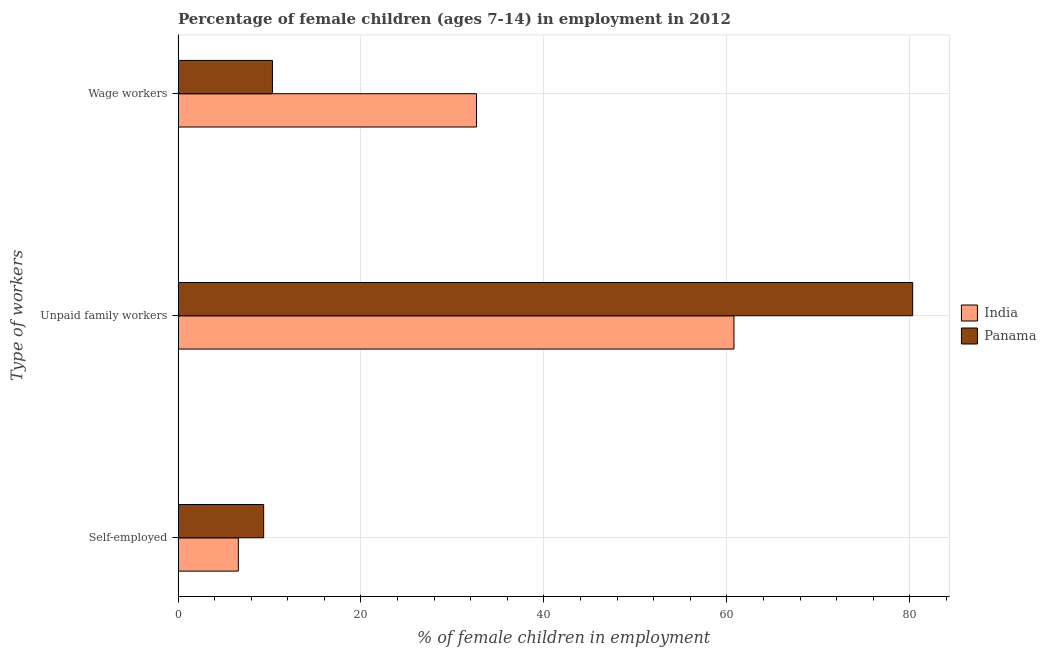How many groups of bars are there?
Your answer should be very brief. 3. Are the number of bars per tick equal to the number of legend labels?
Give a very brief answer. Yes. Are the number of bars on each tick of the Y-axis equal?
Your response must be concise. Yes. How many bars are there on the 1st tick from the top?
Ensure brevity in your answer.  2. How many bars are there on the 2nd tick from the bottom?
Provide a succinct answer. 2. What is the label of the 1st group of bars from the top?
Ensure brevity in your answer.  Wage workers. What is the percentage of children employed as unpaid family workers in Panama?
Your answer should be compact. 80.32. Across all countries, what is the maximum percentage of self employed children?
Ensure brevity in your answer.  9.36. Across all countries, what is the minimum percentage of children employed as wage workers?
Your response must be concise. 10.32. In which country was the percentage of children employed as unpaid family workers maximum?
Provide a short and direct response. Panama. In which country was the percentage of children employed as unpaid family workers minimum?
Give a very brief answer. India. What is the total percentage of self employed children in the graph?
Provide a succinct answer. 15.95. What is the difference between the percentage of children employed as unpaid family workers in Panama and that in India?
Your answer should be very brief. 19.54. What is the difference between the percentage of children employed as unpaid family workers in Panama and the percentage of children employed as wage workers in India?
Provide a succinct answer. 47.69. What is the average percentage of children employed as unpaid family workers per country?
Ensure brevity in your answer.  70.55. What is the difference between the percentage of children employed as wage workers and percentage of self employed children in India?
Make the answer very short. 26.04. What is the ratio of the percentage of children employed as wage workers in Panama to that in India?
Offer a terse response. 0.32. Is the difference between the percentage of children employed as wage workers in Panama and India greater than the difference between the percentage of children employed as unpaid family workers in Panama and India?
Your response must be concise. No. What is the difference between the highest and the second highest percentage of self employed children?
Make the answer very short. 2.77. What is the difference between the highest and the lowest percentage of children employed as unpaid family workers?
Your answer should be compact. 19.54. In how many countries, is the percentage of self employed children greater than the average percentage of self employed children taken over all countries?
Give a very brief answer. 1. What does the 1st bar from the top in Unpaid family workers represents?
Your answer should be compact. Panama. Is it the case that in every country, the sum of the percentage of self employed children and percentage of children employed as unpaid family workers is greater than the percentage of children employed as wage workers?
Make the answer very short. Yes. Are all the bars in the graph horizontal?
Make the answer very short. Yes. How many countries are there in the graph?
Make the answer very short. 2. Does the graph contain any zero values?
Your answer should be compact. No. Where does the legend appear in the graph?
Provide a short and direct response. Center right. How many legend labels are there?
Offer a terse response. 2. What is the title of the graph?
Ensure brevity in your answer.  Percentage of female children (ages 7-14) in employment in 2012. What is the label or title of the X-axis?
Offer a terse response. % of female children in employment. What is the label or title of the Y-axis?
Your response must be concise. Type of workers. What is the % of female children in employment of India in Self-employed?
Offer a very short reply. 6.59. What is the % of female children in employment in Panama in Self-employed?
Give a very brief answer. 9.36. What is the % of female children in employment in India in Unpaid family workers?
Offer a terse response. 60.78. What is the % of female children in employment in Panama in Unpaid family workers?
Provide a short and direct response. 80.32. What is the % of female children in employment of India in Wage workers?
Ensure brevity in your answer.  32.63. What is the % of female children in employment in Panama in Wage workers?
Your answer should be very brief. 10.32. Across all Type of workers, what is the maximum % of female children in employment of India?
Offer a very short reply. 60.78. Across all Type of workers, what is the maximum % of female children in employment in Panama?
Offer a very short reply. 80.32. Across all Type of workers, what is the minimum % of female children in employment in India?
Provide a succinct answer. 6.59. Across all Type of workers, what is the minimum % of female children in employment in Panama?
Ensure brevity in your answer.  9.36. What is the difference between the % of female children in employment of India in Self-employed and that in Unpaid family workers?
Provide a short and direct response. -54.19. What is the difference between the % of female children in employment in Panama in Self-employed and that in Unpaid family workers?
Provide a succinct answer. -70.96. What is the difference between the % of female children in employment in India in Self-employed and that in Wage workers?
Your answer should be compact. -26.04. What is the difference between the % of female children in employment in Panama in Self-employed and that in Wage workers?
Your response must be concise. -0.96. What is the difference between the % of female children in employment in India in Unpaid family workers and that in Wage workers?
Offer a very short reply. 28.15. What is the difference between the % of female children in employment of India in Self-employed and the % of female children in employment of Panama in Unpaid family workers?
Provide a short and direct response. -73.73. What is the difference between the % of female children in employment of India in Self-employed and the % of female children in employment of Panama in Wage workers?
Your answer should be very brief. -3.73. What is the difference between the % of female children in employment of India in Unpaid family workers and the % of female children in employment of Panama in Wage workers?
Keep it short and to the point. 50.46. What is the average % of female children in employment in India per Type of workers?
Your answer should be compact. 33.33. What is the average % of female children in employment in Panama per Type of workers?
Provide a succinct answer. 33.33. What is the difference between the % of female children in employment in India and % of female children in employment in Panama in Self-employed?
Give a very brief answer. -2.77. What is the difference between the % of female children in employment in India and % of female children in employment in Panama in Unpaid family workers?
Make the answer very short. -19.54. What is the difference between the % of female children in employment of India and % of female children in employment of Panama in Wage workers?
Provide a short and direct response. 22.31. What is the ratio of the % of female children in employment in India in Self-employed to that in Unpaid family workers?
Your answer should be compact. 0.11. What is the ratio of the % of female children in employment of Panama in Self-employed to that in Unpaid family workers?
Provide a succinct answer. 0.12. What is the ratio of the % of female children in employment of India in Self-employed to that in Wage workers?
Your answer should be very brief. 0.2. What is the ratio of the % of female children in employment in Panama in Self-employed to that in Wage workers?
Offer a terse response. 0.91. What is the ratio of the % of female children in employment of India in Unpaid family workers to that in Wage workers?
Provide a short and direct response. 1.86. What is the ratio of the % of female children in employment of Panama in Unpaid family workers to that in Wage workers?
Offer a very short reply. 7.78. What is the difference between the highest and the second highest % of female children in employment of India?
Ensure brevity in your answer.  28.15. What is the difference between the highest and the second highest % of female children in employment in Panama?
Your answer should be compact. 70. What is the difference between the highest and the lowest % of female children in employment of India?
Provide a short and direct response. 54.19. What is the difference between the highest and the lowest % of female children in employment in Panama?
Offer a terse response. 70.96. 